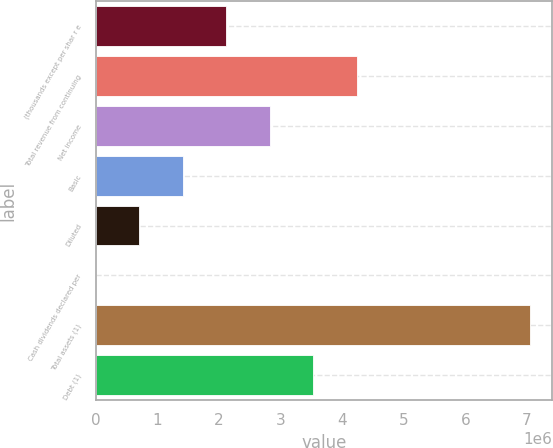<chart> <loc_0><loc_0><loc_500><loc_500><bar_chart><fcel>(thousands except per shar r e<fcel>Total revenue from continuing<fcel>Net income<fcel>Basic<fcel>Diluted<fcel>Cash dividends declared per<fcel>Total assets (1)<fcel>Debt (1)<nl><fcel>2.11763e+06<fcel>4.23527e+06<fcel>2.82351e+06<fcel>1.41176e+06<fcel>705879<fcel>1.57<fcel>7.05878e+06<fcel>3.52939e+06<nl></chart> 